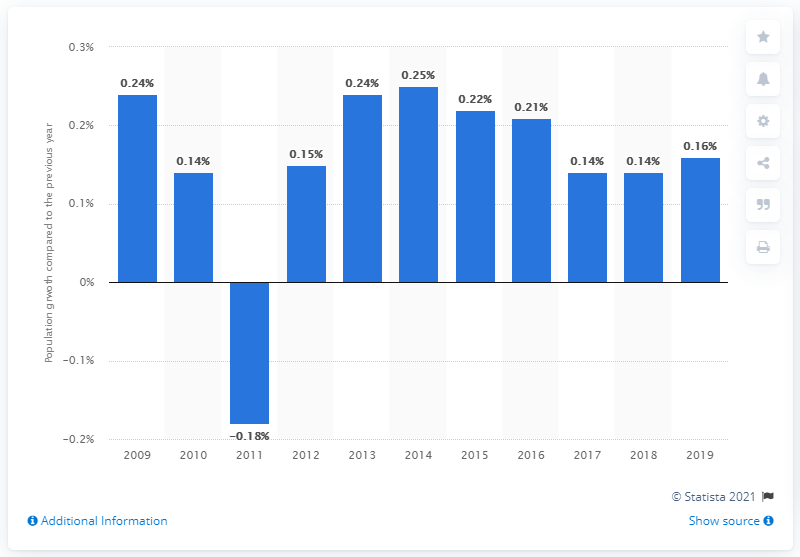Point out several critical features in this image. The population of the European Union increased by 0.16% in 2019. 